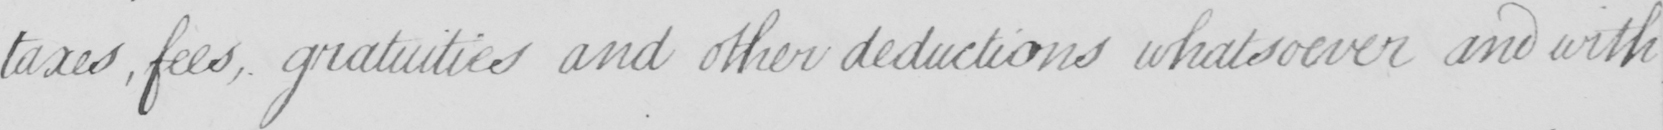What text is written in this handwritten line? taxes , fees , gratuities and other deductions whatsoever and with 